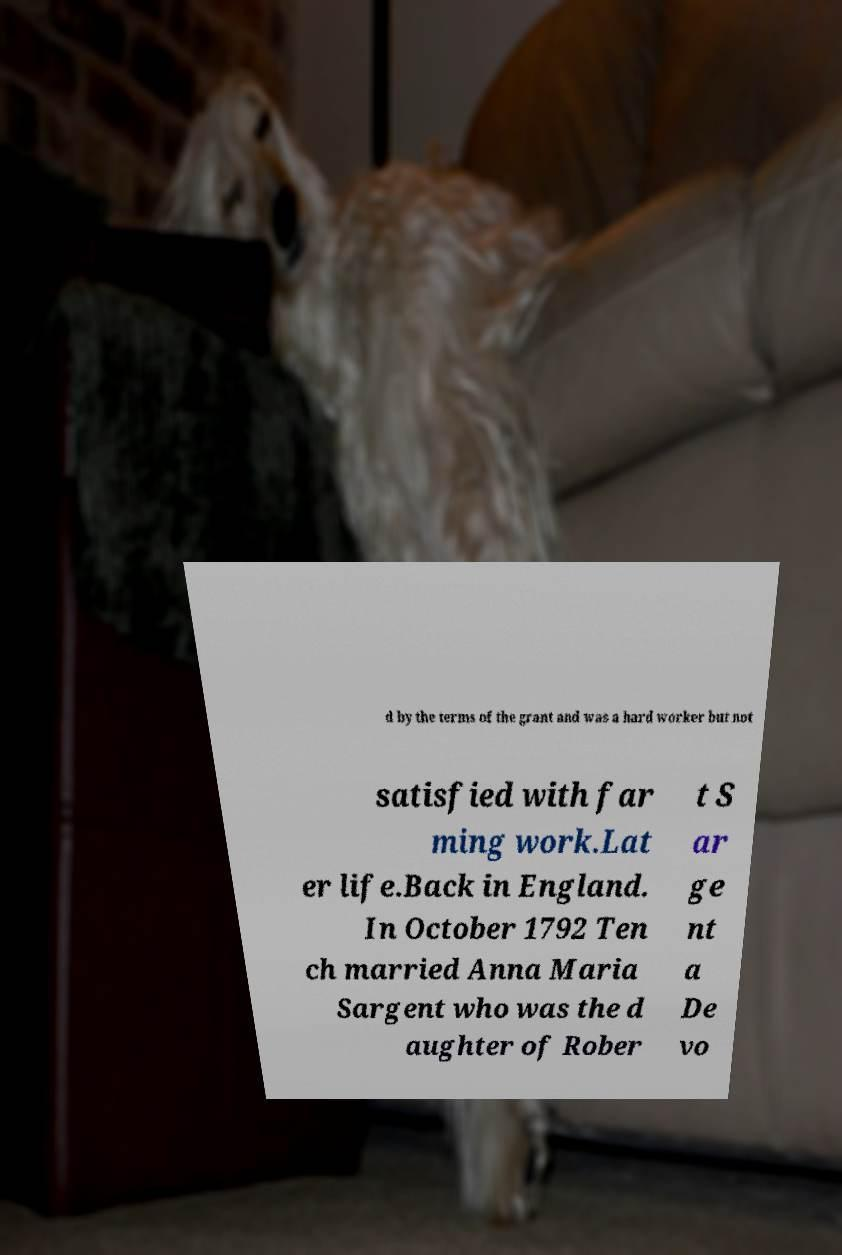What messages or text are displayed in this image? I need them in a readable, typed format. d by the terms of the grant and was a hard worker but not satisfied with far ming work.Lat er life.Back in England. In October 1792 Ten ch married Anna Maria Sargent who was the d aughter of Rober t S ar ge nt a De vo 